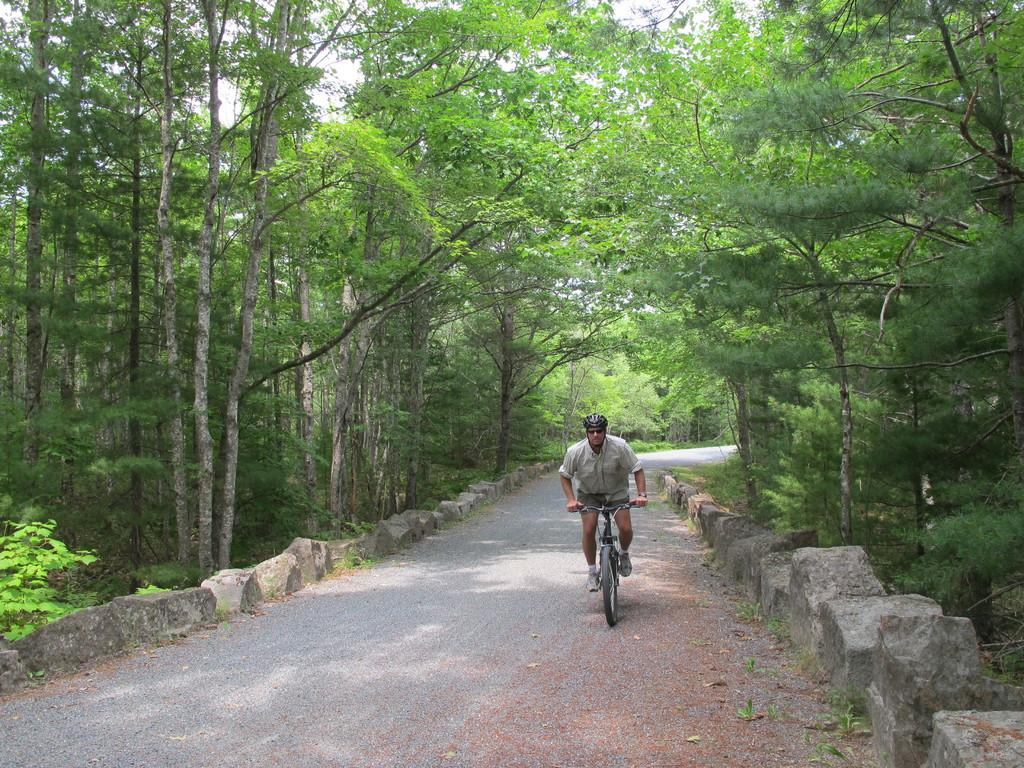What is the person in the image doing? There is a person sitting on a bicycle in the image. What can be seen in the background of the image? The road is visible in the image. What type of vegetation is present on both sides of the image? There are trees on the left side and the right side of the image. What type of cactus can be seen in the image? There is no cactus present in the image; it features a person on a bicycle, a road, and trees. 